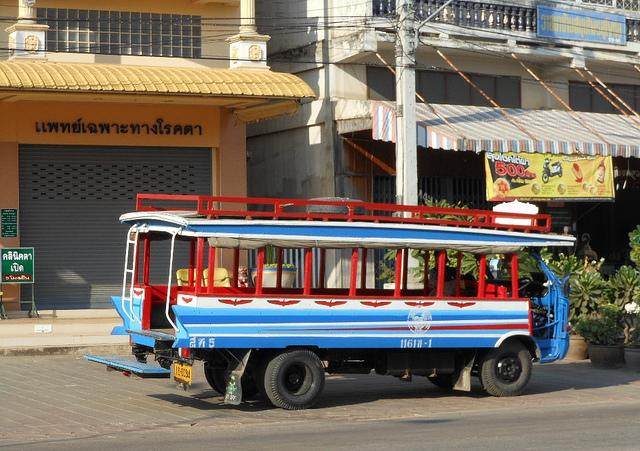The color scheme of this vehicle represents what flag? usa 